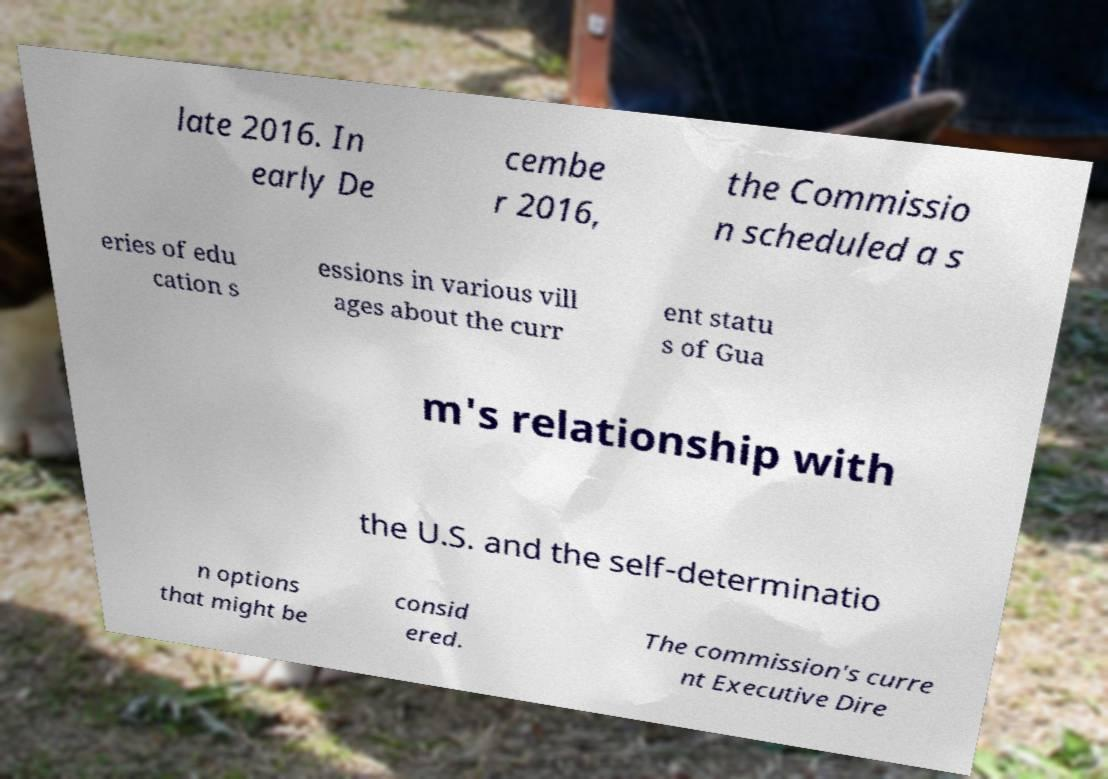Could you extract and type out the text from this image? late 2016. In early De cembe r 2016, the Commissio n scheduled a s eries of edu cation s essions in various vill ages about the curr ent statu s of Gua m's relationship with the U.S. and the self-determinatio n options that might be consid ered. The commission's curre nt Executive Dire 